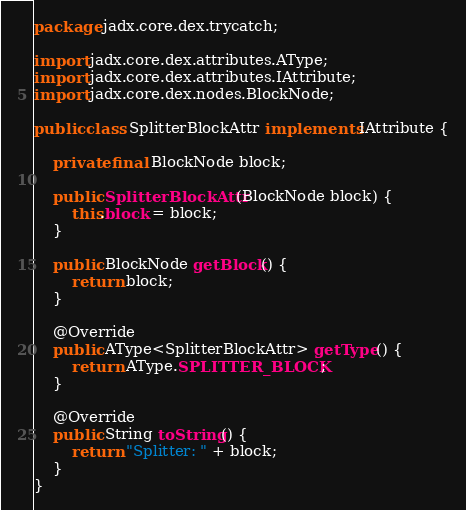Convert code to text. <code><loc_0><loc_0><loc_500><loc_500><_Java_>package jadx.core.dex.trycatch;

import jadx.core.dex.attributes.AType;
import jadx.core.dex.attributes.IAttribute;
import jadx.core.dex.nodes.BlockNode;

public class SplitterBlockAttr implements IAttribute {

	private final BlockNode block;

	public SplitterBlockAttr(BlockNode block) {
		this.block = block;
	}

	public BlockNode getBlock() {
		return block;
	}

	@Override
	public AType<SplitterBlockAttr> getType() {
		return AType.SPLITTER_BLOCK;
	}

	@Override
	public String toString() {
		return "Splitter: " + block;
	}
}
</code> 